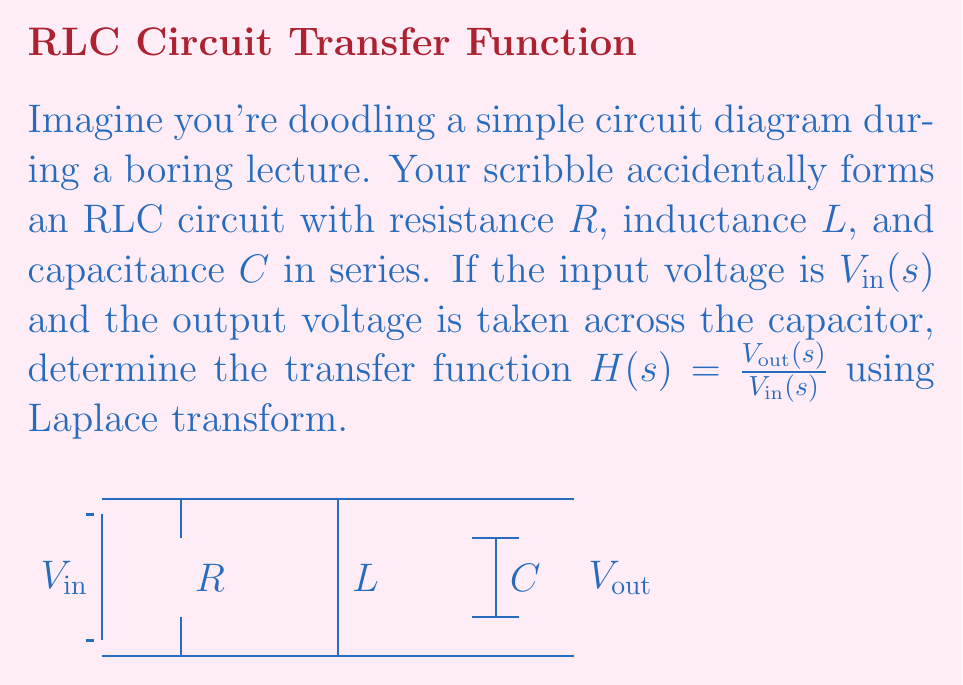Give your solution to this math problem. Let's solve this step-by-step:

1) In the s-domain, the impedances of the components are:
   - Resistor: $Z_R = R$
   - Inductor: $Z_L = sL$
   - Capacitor: $Z_C = \frac{1}{sC}$

2) The total impedance of the circuit is:

   $$Z_{total} = R + sL + \frac{1}{sC}$$

3) The current in the circuit is:

   $$I(s) = \frac{V_{in}(s)}{Z_{total}} = \frac{V_{in}(s)}{R + sL + \frac{1}{sC}}$$

4) The output voltage is taken across the capacitor, so:

   $$V_{out}(s) = I(s) \cdot Z_C = I(s) \cdot \frac{1}{sC}$$

5) Substituting $I(s)$ from step 3:

   $$V_{out}(s) = \frac{V_{in}(s)}{R + sL + \frac{1}{sC}} \cdot \frac{1}{sC}$$

6) The transfer function is defined as $H(s) = \frac{V_{out}(s)}{V_{in}(s)}$, so:

   $$H(s) = \frac{V_{out}(s)}{V_{in}(s)} = \frac{1}{sC(R + sL + \frac{1}{sC})}$$

7) Simplifying:

   $$H(s) = \frac{1}{s^2LC + sRC + 1}$$

This is the transfer function of the RLC circuit.
Answer: $$H(s) = \frac{1}{s^2LC + sRC + 1}$$ 